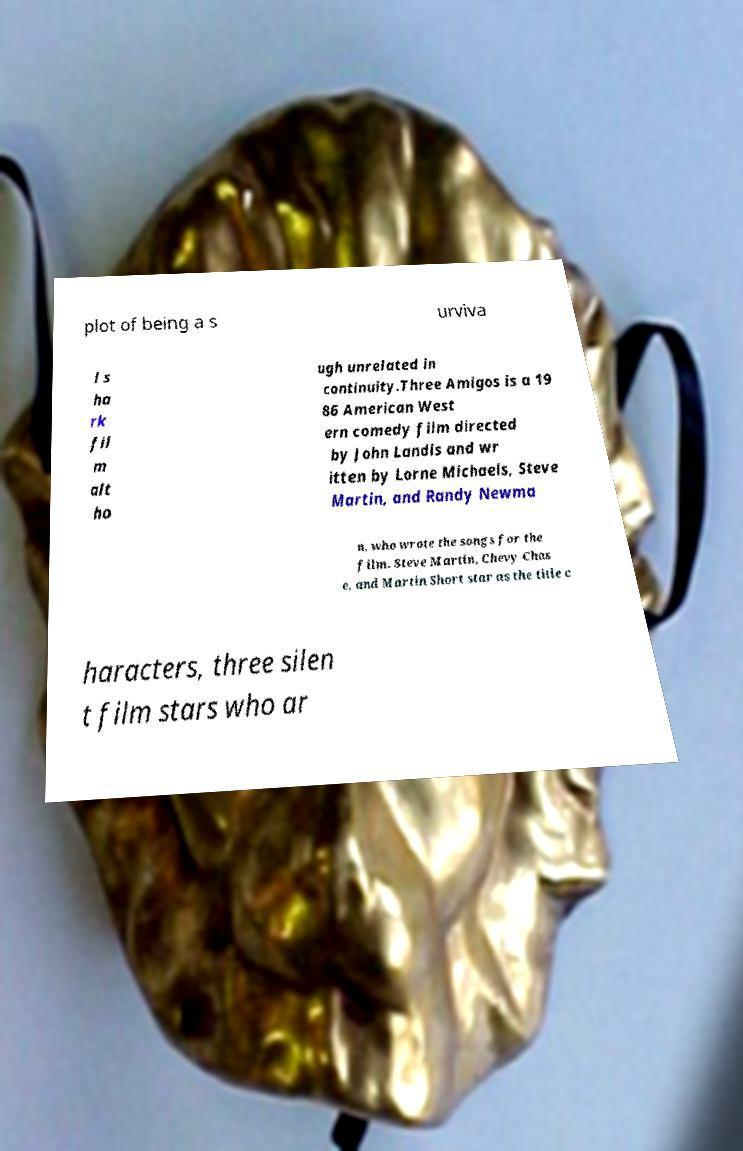Please identify and transcribe the text found in this image. plot of being a s urviva l s ha rk fil m alt ho ugh unrelated in continuity.Three Amigos is a 19 86 American West ern comedy film directed by John Landis and wr itten by Lorne Michaels, Steve Martin, and Randy Newma n, who wrote the songs for the film. Steve Martin, Chevy Chas e, and Martin Short star as the title c haracters, three silen t film stars who ar 